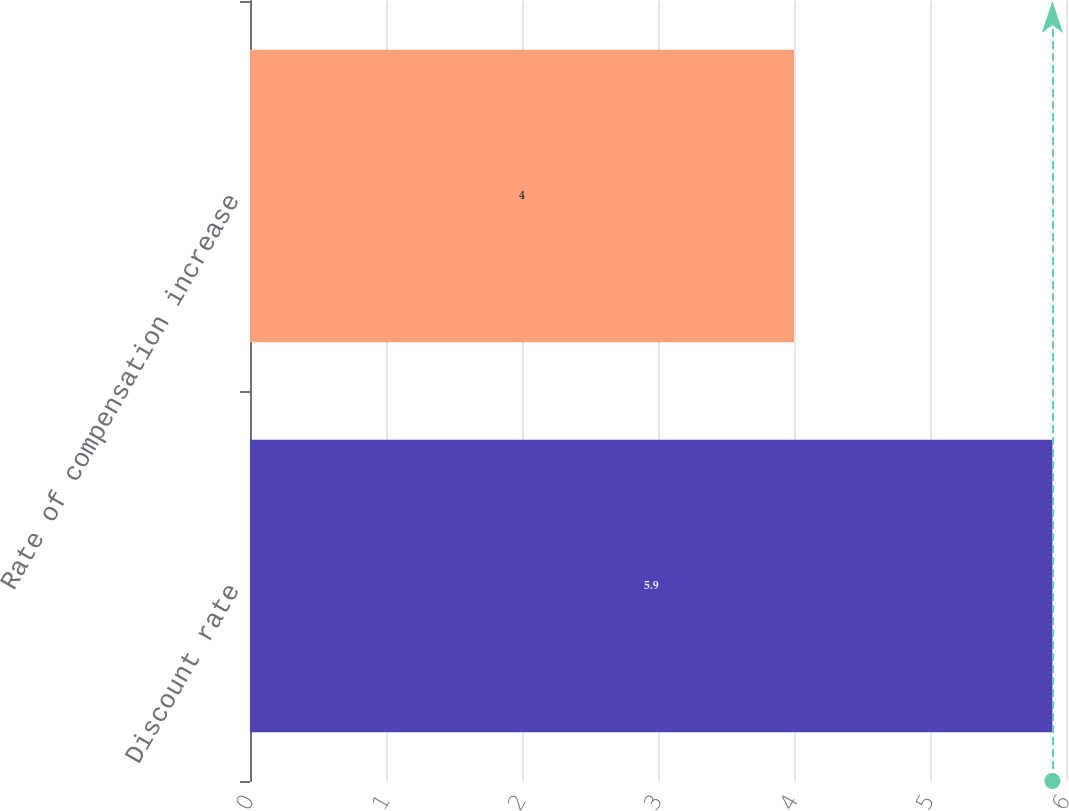<chart> <loc_0><loc_0><loc_500><loc_500><bar_chart><fcel>Discount rate<fcel>Rate of compensation increase<nl><fcel>5.9<fcel>4<nl></chart> 